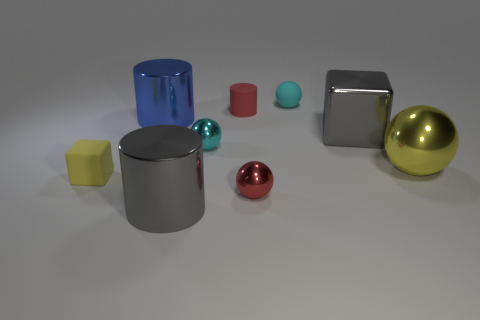Subtract all yellow spheres. How many spheres are left? 3 Subtract all large balls. How many balls are left? 3 Subtract all brown spheres. Subtract all gray cylinders. How many spheres are left? 4 Add 1 big cylinders. How many objects exist? 10 Subtract all spheres. How many objects are left? 5 Add 6 brown shiny blocks. How many brown shiny blocks exist? 6 Subtract 0 cyan cubes. How many objects are left? 9 Subtract all yellow shiny balls. Subtract all cyan shiny objects. How many objects are left? 7 Add 4 cyan objects. How many cyan objects are left? 6 